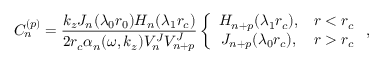Convert formula to latex. <formula><loc_0><loc_0><loc_500><loc_500>C _ { n } ^ { ( p ) } = \frac { k _ { z } J _ { n } ( \lambda _ { 0 } r _ { 0 } ) H _ { n } ( \lambda _ { 1 } r _ { c } ) } { 2 r _ { c } \alpha _ { n } ( \omega , k _ { z } ) V _ { n } ^ { J } V _ { n + p } ^ { J } } \left \{ \begin{array} { c c } { H _ { n + p } ( \lambda _ { 1 } r _ { c } ) , } & { r < r _ { c } } \\ { J _ { n + p } ( \lambda _ { 0 } r _ { c } ) , } & { r > r _ { c } } \end{array} ,</formula> 